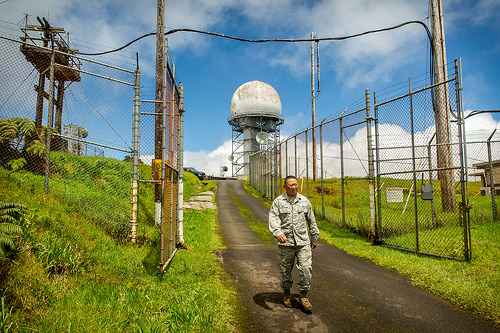<image>
Is there a fence behind the man? Yes. From this viewpoint, the fence is positioned behind the man, with the man partially or fully occluding the fence. 